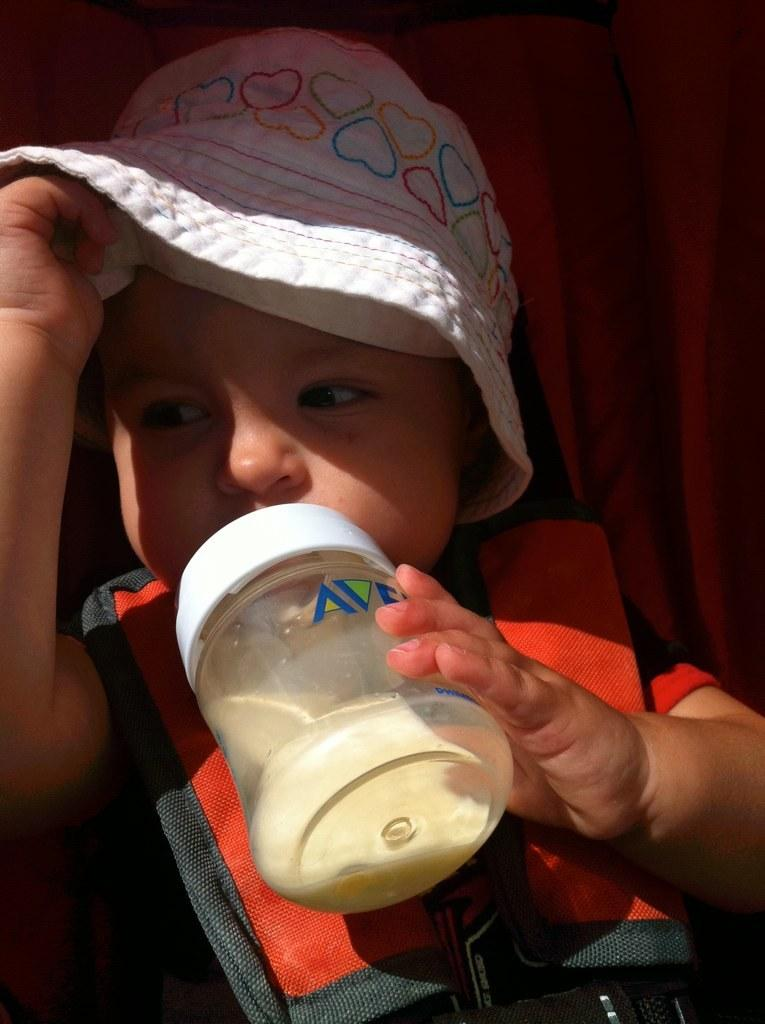What is the main subject of the image? The main subject of the image is a kid. What is the kid wearing on their head? The kid is wearing a cap. What is the kid holding in their hand? The kid is holding a milk bottle. What can be seen in the background of the image? There is a curtain in the background of the image. How many pizzas are on the table in the image? There are no pizzas present in the image; it only features a kid wearing a cap and holding a milk bottle, with a curtain in the background. 